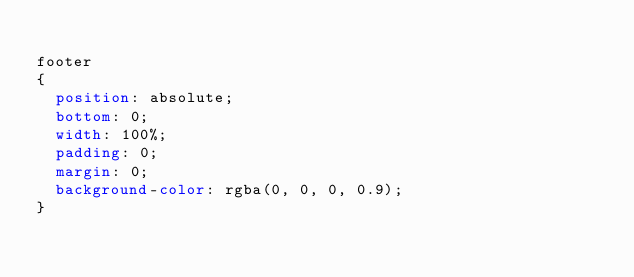<code> <loc_0><loc_0><loc_500><loc_500><_CSS_>
footer
{
  position: absolute;
  bottom: 0;
  width: 100%;
  padding: 0;
  margin: 0;
  background-color: rgba(0, 0, 0, 0.9);
}
</code> 